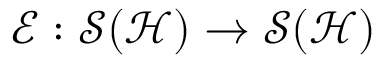<formula> <loc_0><loc_0><loc_500><loc_500>\mathcal { E } \colon \mathcal { S } ( \mathcal { H } ) \rightarrow \mathcal { S } ( \mathcal { H } )</formula> 